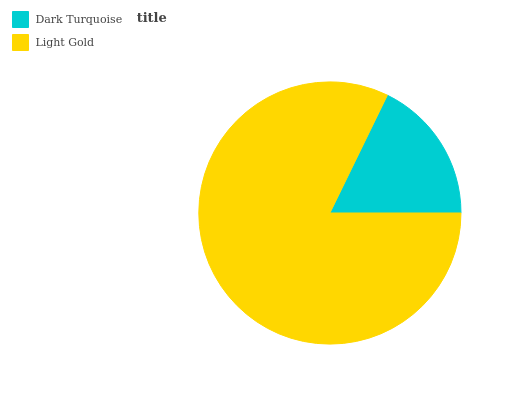Is Dark Turquoise the minimum?
Answer yes or no. Yes. Is Light Gold the maximum?
Answer yes or no. Yes. Is Light Gold the minimum?
Answer yes or no. No. Is Light Gold greater than Dark Turquoise?
Answer yes or no. Yes. Is Dark Turquoise less than Light Gold?
Answer yes or no. Yes. Is Dark Turquoise greater than Light Gold?
Answer yes or no. No. Is Light Gold less than Dark Turquoise?
Answer yes or no. No. Is Light Gold the high median?
Answer yes or no. Yes. Is Dark Turquoise the low median?
Answer yes or no. Yes. Is Dark Turquoise the high median?
Answer yes or no. No. Is Light Gold the low median?
Answer yes or no. No. 